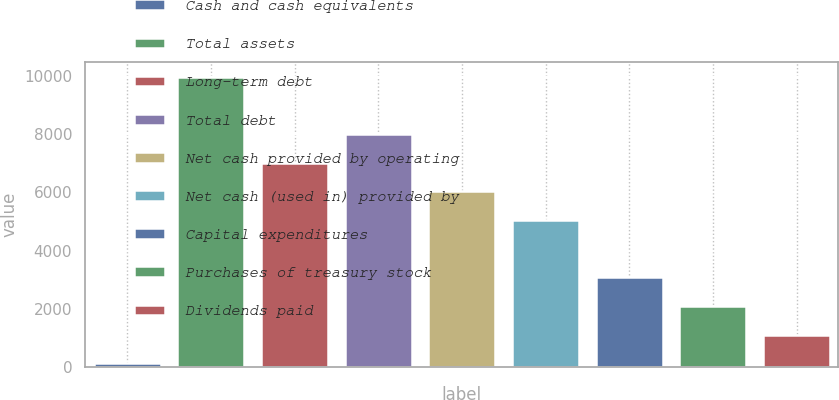Convert chart to OTSL. <chart><loc_0><loc_0><loc_500><loc_500><bar_chart><fcel>Cash and cash equivalents<fcel>Total assets<fcel>Long-term debt<fcel>Total debt<fcel>Net cash provided by operating<fcel>Net cash (used in) provided by<fcel>Capital expenditures<fcel>Purchases of treasury stock<fcel>Dividends paid<nl><fcel>133<fcel>9962<fcel>7013.3<fcel>7996.2<fcel>6030.4<fcel>5047.5<fcel>3081.7<fcel>2098.8<fcel>1115.9<nl></chart> 